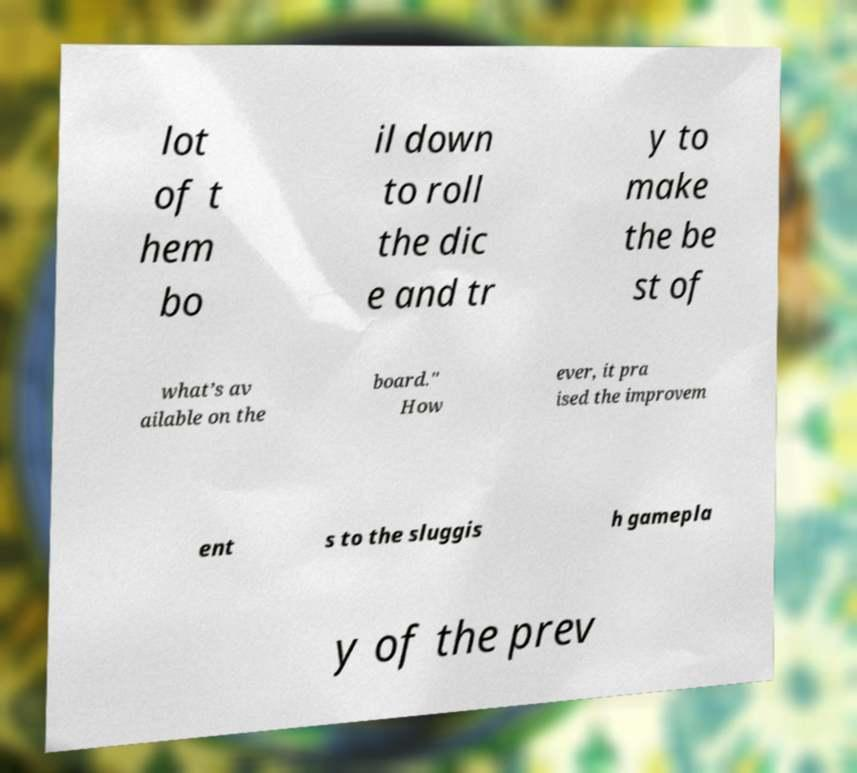For documentation purposes, I need the text within this image transcribed. Could you provide that? lot of t hem bo il down to roll the dic e and tr y to make the be st of what’s av ailable on the board." How ever, it pra ised the improvem ent s to the sluggis h gamepla y of the prev 